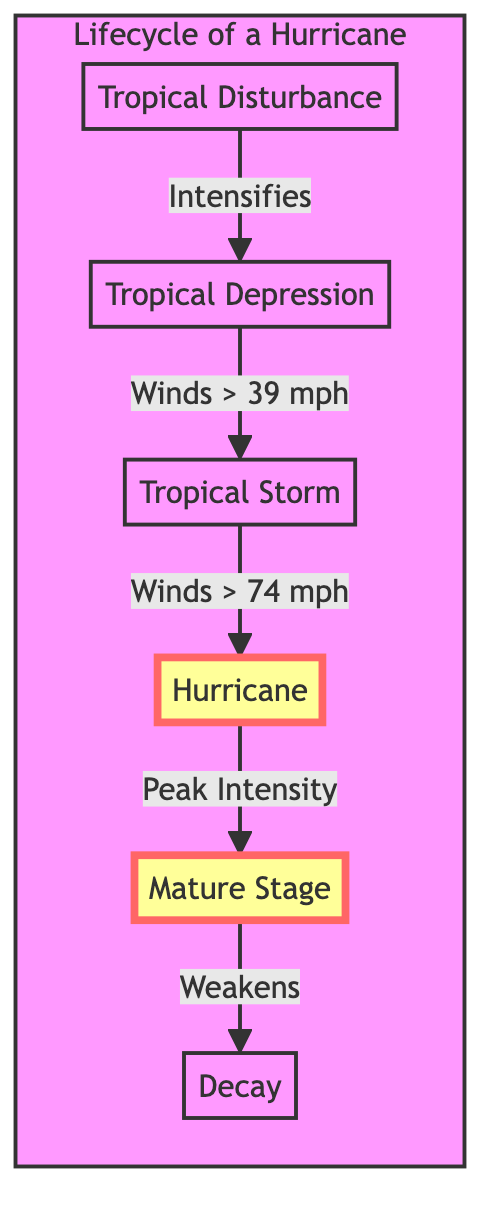What is the first stage of a hurricane's lifecycle? The diagram shows the flow of a hurricane's lifecycle starting with "Tropical Disturbance" as the first node, indicating that this is the initial stage.
Answer: Tropical Disturbance How many distinct stages are shown in the diagram? The diagram presents a total of six stages: Tropical Disturbance, Tropical Depression, Tropical Storm, Hurricane, Mature Stage, and Decay. Counting these stages leads to a total of six.
Answer: 6 What are the maximum sustained winds for a Tropical Storm? According to the diagram, a Tropical Storm is defined as having sustained winds between 39 and 73 mph, with the upper limit being 73 mph.
Answer: 73 mph What occurs after the Tropical Depression stage according to the diagram? The sequence in the diagram indicates that after the Tropical Depression (B), the next stage that follows is the Tropical Storm (C), which is linked by an arrow labeled "Winds > 39 mph".
Answer: Tropical Storm At what point in the lifecycle is the storm classified as a hurricane? From the visual flowchart, a storm is classified as a Hurricane (D) when it reaches sustained winds exceeding 74 mph, as indicated by the connection from Tropical Storm (C) to Hurricane (D).
Answer: Winds > 74 mph What is the last stage of a hurricane's lifecycle depicted in the diagram? The final node in the sequence, which is linked to all previous stages, represents the "Decay" stage, so it is evident that this is the last stage of the hurricane's lifecycle.
Answer: Decay Which stage is characterized by peak intensity? The Mature Stage (E) is noted for occurring when the hurricane reaches its peak intensity, as indicated in the flowchart.
Answer: Mature Stage What does the arrow between Mature Stage and Decay indicate? The arrow between these two nodes indicates a progression from the Mature Stage (E) where the hurricane peaks to the Decay (F) stage, which represents the weakening of the hurricane.
Answer: Weakens What real-world example is provided for the Hurricane stage? Checking the Hurricane (D) node in the diagram, it cites "Hurricane Katrina (2005), Category 5" as a real-world example to illustrate this stage.
Answer: Hurricane Katrina (2005), Category 5 